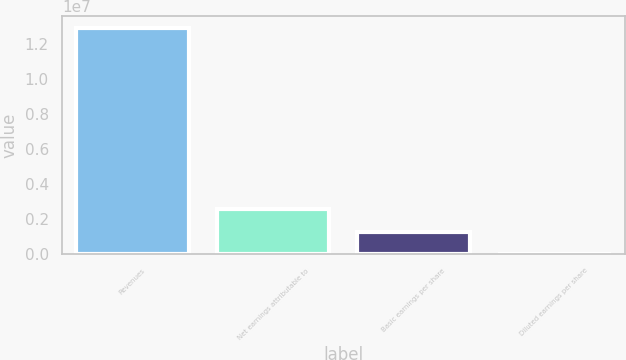Convert chart. <chart><loc_0><loc_0><loc_500><loc_500><bar_chart><fcel>Revenues<fcel>Net earnings attributable to<fcel>Basic earnings per share<fcel>Diluted earnings per share<nl><fcel>1.29448e+07<fcel>2.58897e+06<fcel>1.29449e+06<fcel>2.54<nl></chart> 